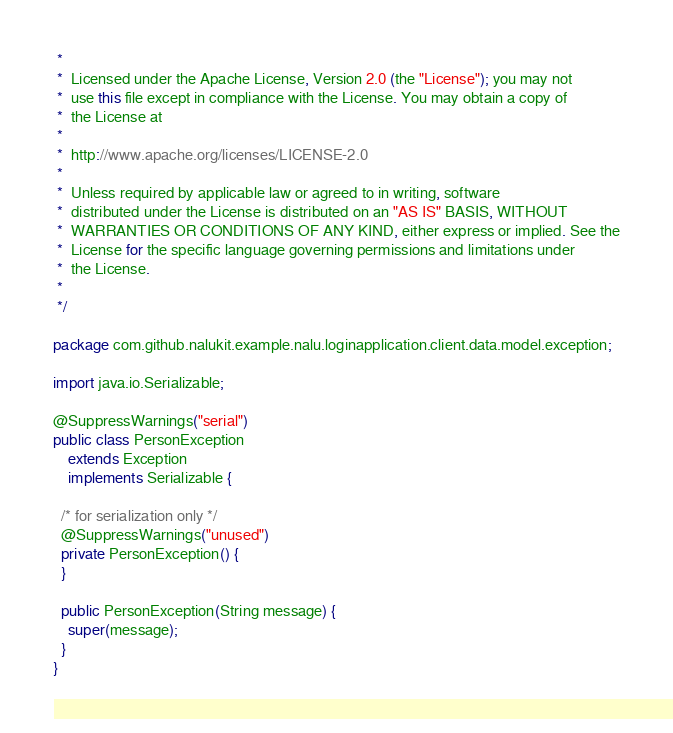Convert code to text. <code><loc_0><loc_0><loc_500><loc_500><_Java_> *
 *  Licensed under the Apache License, Version 2.0 (the "License"); you may not
 *  use this file except in compliance with the License. You may obtain a copy of
 *  the License at
 *
 *  http://www.apache.org/licenses/LICENSE-2.0
 *
 *  Unless required by applicable law or agreed to in writing, software
 *  distributed under the License is distributed on an "AS IS" BASIS, WITHOUT
 *  WARRANTIES OR CONDITIONS OF ANY KIND, either express or implied. See the
 *  License for the specific language governing permissions and limitations under
 *  the License.
 *
 */

package com.github.nalukit.example.nalu.loginapplication.client.data.model.exception;

import java.io.Serializable;

@SuppressWarnings("serial")
public class PersonException
    extends Exception
    implements Serializable {

  /* for serialization only */
  @SuppressWarnings("unused")
  private PersonException() {
  }

  public PersonException(String message) {
    super(message);
  }
}
</code> 